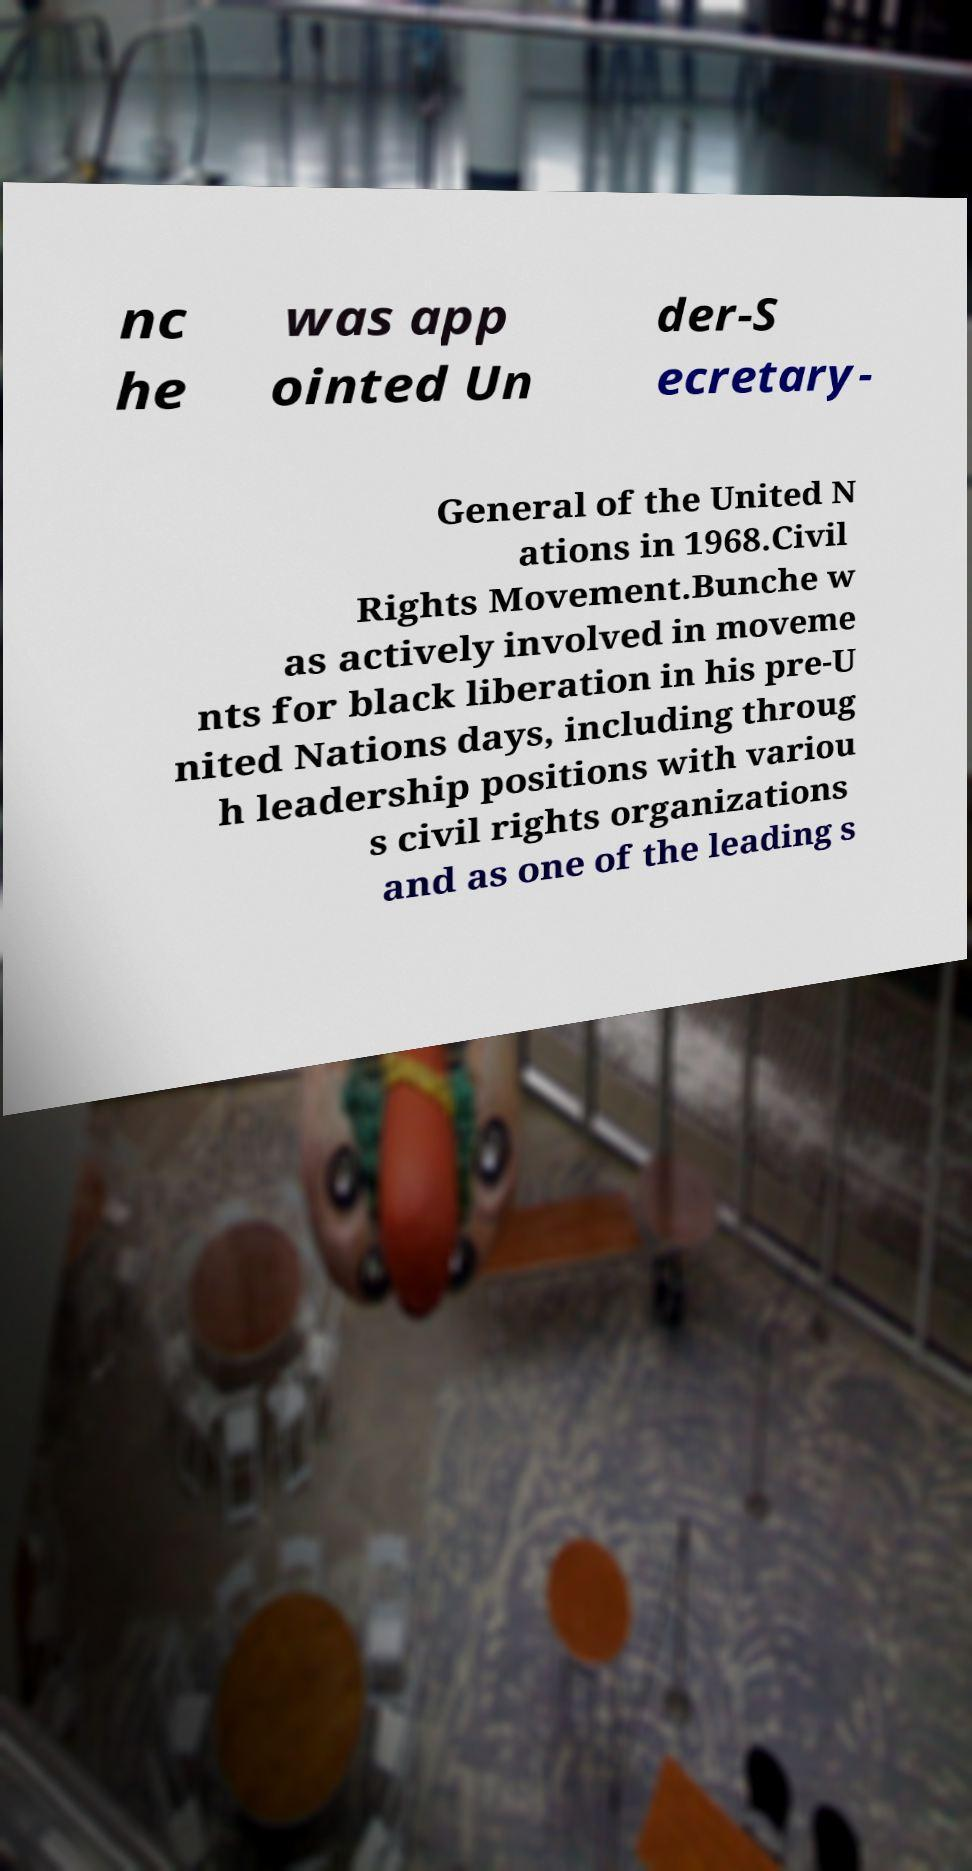Could you assist in decoding the text presented in this image and type it out clearly? nc he was app ointed Un der-S ecretary- General of the United N ations in 1968.Civil Rights Movement.Bunche w as actively involved in moveme nts for black liberation in his pre-U nited Nations days, including throug h leadership positions with variou s civil rights organizations and as one of the leading s 